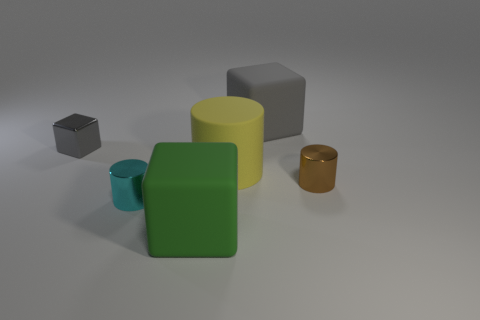The shiny block has what color?
Your answer should be very brief. Gray. What is the material of the small brown cylinder that is behind the cyan metallic cylinder?
Provide a succinct answer. Metal. The gray matte object that is the same shape as the green matte thing is what size?
Your response must be concise. Large. Is the number of brown metallic cylinders that are to the right of the cyan thing less than the number of large yellow rubber cylinders?
Your answer should be compact. No. Are any gray matte things visible?
Provide a short and direct response. Yes. What color is the other small object that is the same shape as the tiny cyan metallic thing?
Make the answer very short. Brown. There is a metal cylinder that is to the left of the small brown metal cylinder; is it the same color as the big matte cylinder?
Provide a short and direct response. No. Does the rubber cylinder have the same size as the brown object?
Ensure brevity in your answer.  No. The brown thing that is made of the same material as the tiny cube is what shape?
Provide a short and direct response. Cylinder. What number of other things are there of the same shape as the brown object?
Your response must be concise. 2. 